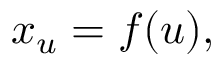Convert formula to latex. <formula><loc_0><loc_0><loc_500><loc_500>x _ { u } = f ( u ) ,</formula> 